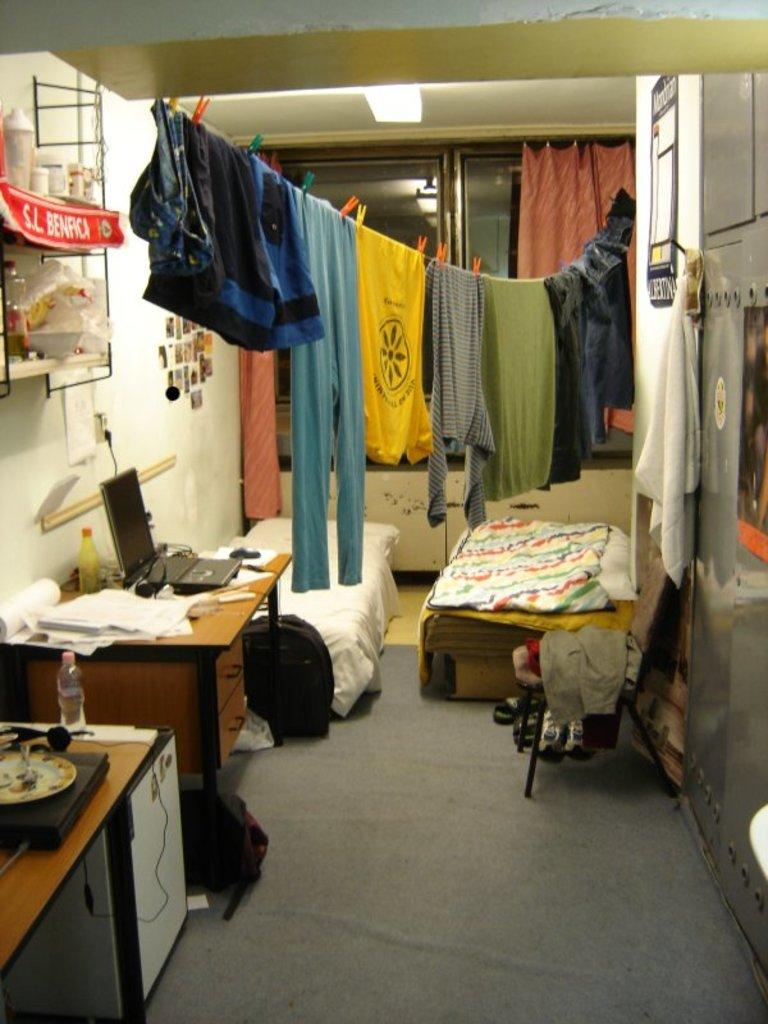What type of space is depicted in the image? The image is of a room. What can be found in the room? There are multiple pieces of furniture, clothes, a table, papers, a laptop, and a bottle in the room. Can you describe the table in the room? The table has papers and a laptop on it, as well as a bottle. What type of event is taking place in the room in the image? There is no indication of an event taking place in the room in the image. How is the distribution of the furniture in the room? The distribution of the furniture in the room cannot be determined from the image alone, as only a limited view of the room is provided. 